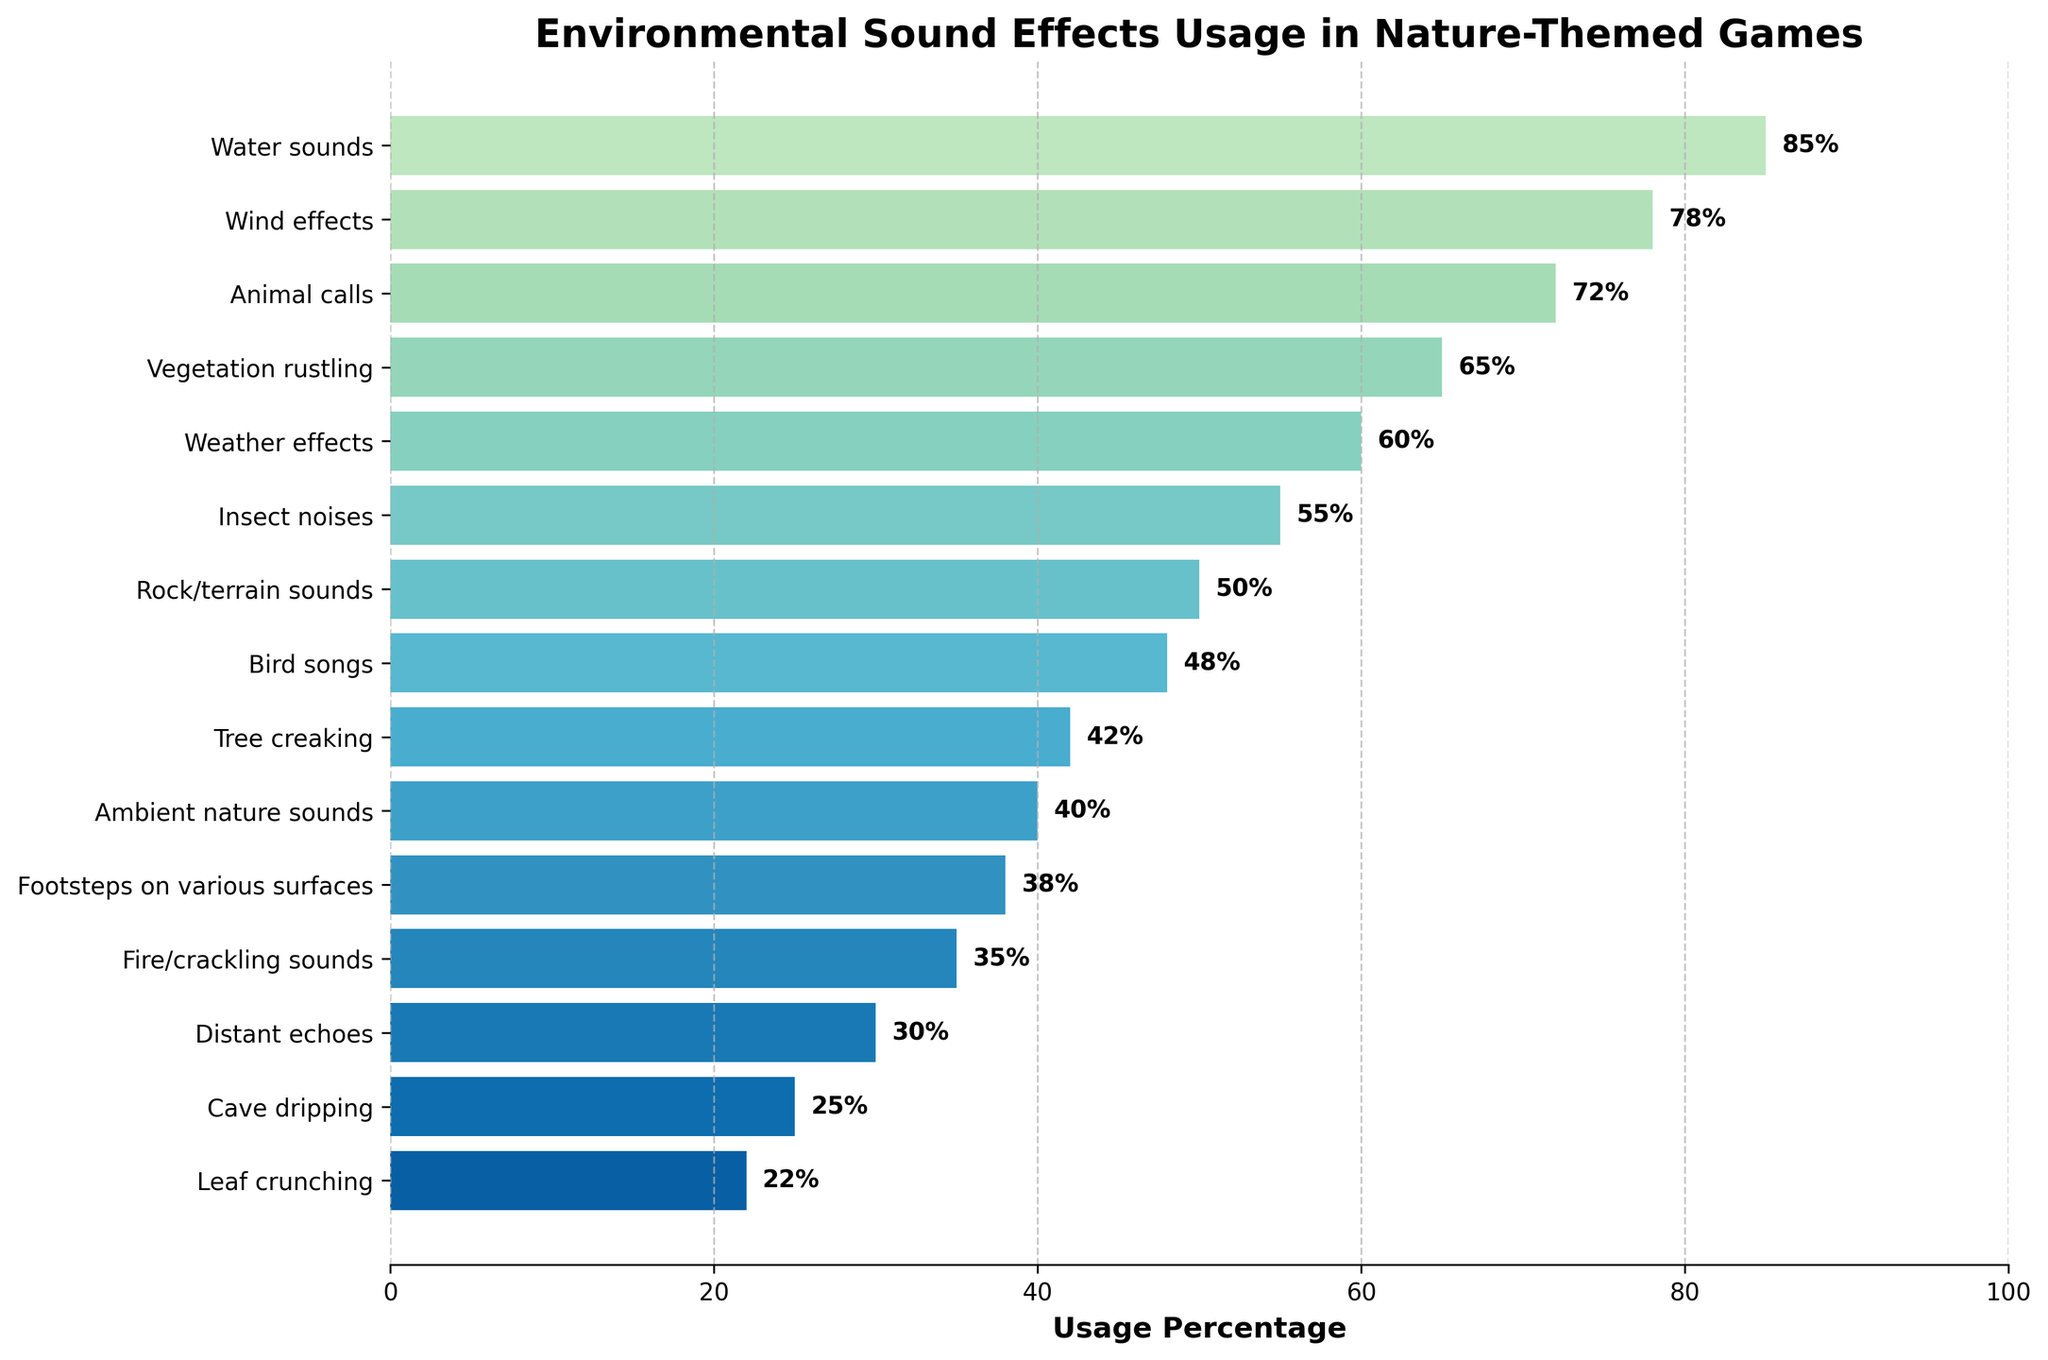Which category has the highest usage percentage? Look for the tallest bar in the chart, which corresponds to the highest usage percentage. In this case, it's the "Water sounds" category.
Answer: Water sounds What is the difference in usage percentage between water sounds and fire/crackling sounds? Find the usage percentages for both categories and subtract the smaller percentage from the larger one. Water sounds have 85%, and fire/crackling sounds have 35%. The difference is 85% - 35% = 50%.
Answer: 50% Which category has a higher usage percentage: animal calls or bird songs? Compare the heights of the bars for "Animal calls" and "Bird songs". "Animal calls" has a usage percentage of 72%, while "Bird songs" has 48%.
Answer: Animal calls What is the total usage percentage of wind effects, vegetation rustling, and weather effects combined? Add the usage percentages for wind effects (78%), vegetation rustling (65%), and weather effects (60%). The total is 78% + 65% + 60% = 203%.
Answer: 203% Is the usage percentage of insect noises greater than or less than that of footsteps on various surfaces? Compare the heights of the bars for "Insect noises" and "Footsteps on various surfaces". Insect noises have a usage percentage of 55%, which is greater than footsteps on various surfaces (38%).
Answer: Greater What is the median usage percentage for all categories? List all the usage percentages in ascending order and find the middle value. The ordered values are: 22, 25, 30, 35, 38, 40, 42, 48, 50, 55, 60, 65, 72, 78, 85. The median is the 8th value, which is 48%.
Answer: 48% How many categories have usage percentages above 70%? Count the bars with usage percentages greater than 70%. The categories are Water sounds (85%), Wind effects (78%), and Animal calls (72%), totaling 3 categories.
Answer: 3 What are the three least used environmental sound effects? Identify the three shortest bars in the chart. They correspond to Leaf crunching (22%), Cave dripping (25%), and Distant echoes (30%).
Answer: Leaf crunching, Cave dripping, Distant echoes Which categories have usage percentages between 40% and 60%? Look for bars within the 40%-60% range. The categories are Weather effects (60%), Insect noises (55%), Rock/terrain sounds (50%), and Bird songs (48%).
Answer: Weather effects, Insect noises, Rock/terrain sounds, Bird songs What is the average usage percentage of the top 5 most used categories? Identify the top 5 categories by sorting the percentages in descending order: Water sounds (85%), Wind effects (78%), Animal calls (72%), Vegetation rustling (65%), and Weather effects (60%). The average is (85 + 78 + 72 + 65 + 60) / 5 = 72%.
Answer: 72% 